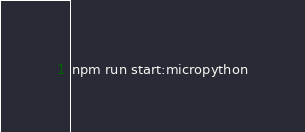Convert code to text. <code><loc_0><loc_0><loc_500><loc_500><_Bash_>npm run start:micropython
</code> 